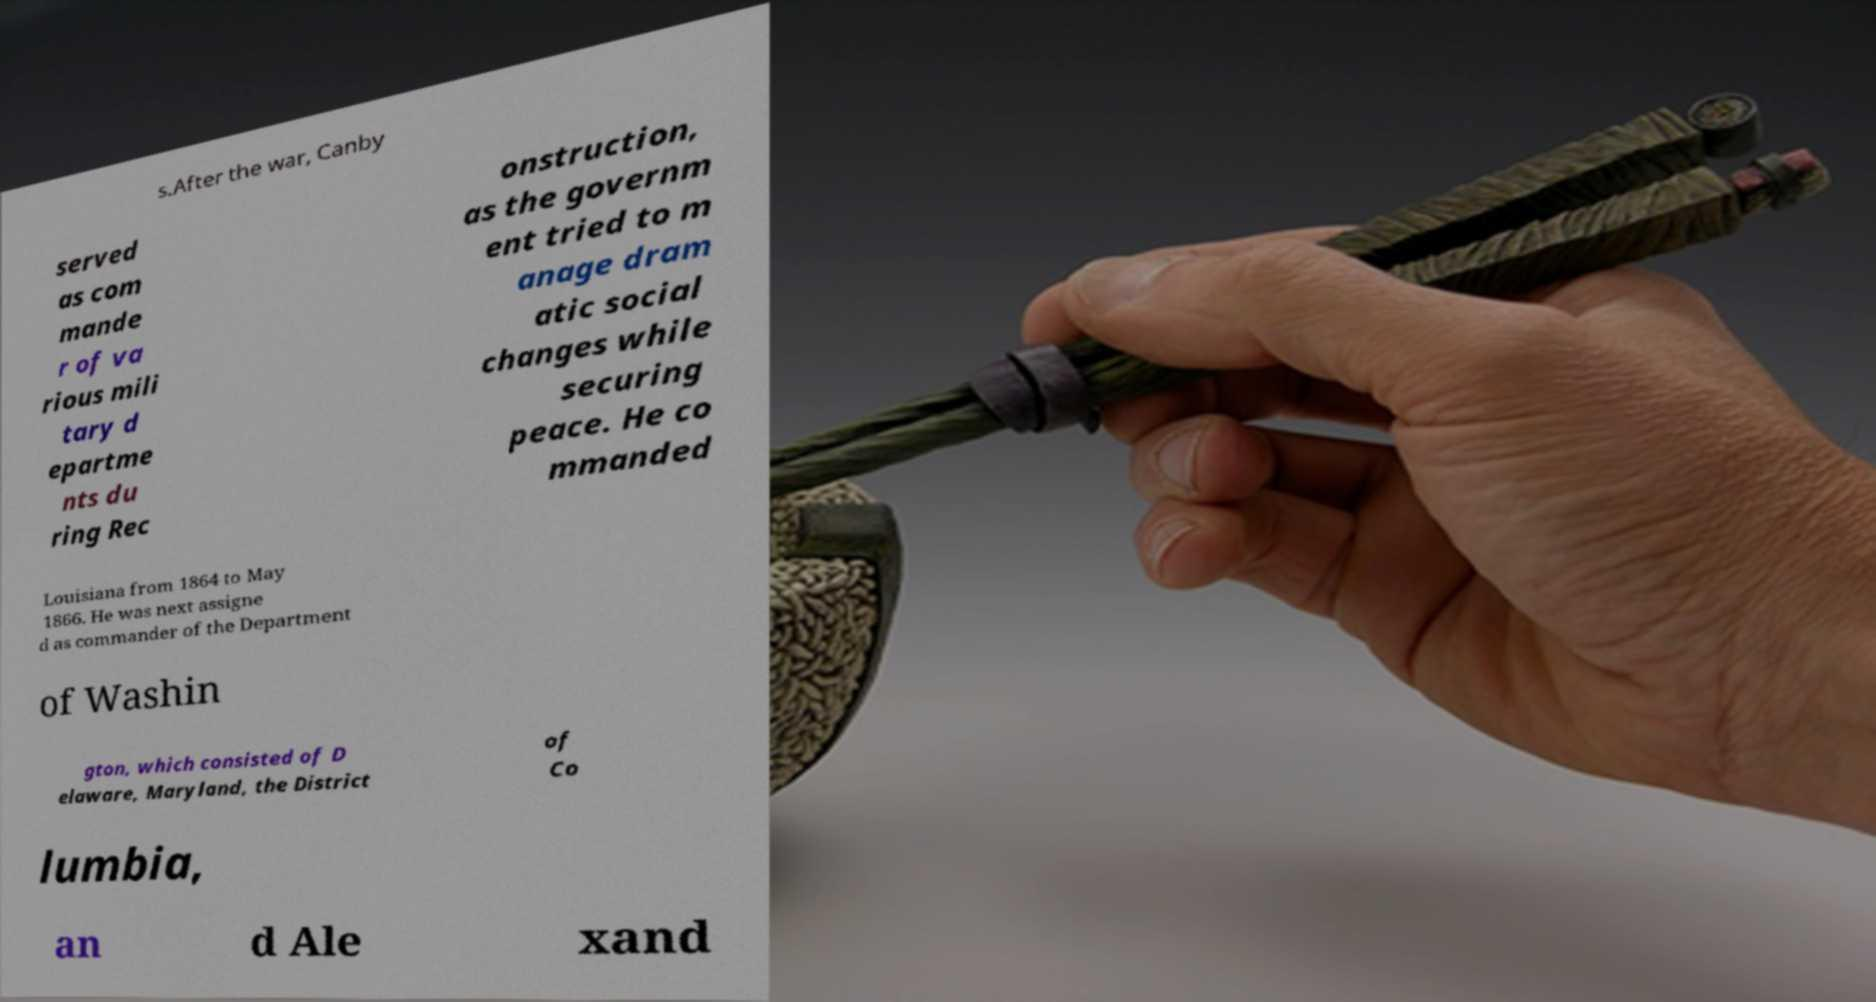Could you extract and type out the text from this image? s.After the war, Canby served as com mande r of va rious mili tary d epartme nts du ring Rec onstruction, as the governm ent tried to m anage dram atic social changes while securing peace. He co mmanded Louisiana from 1864 to May 1866. He was next assigne d as commander of the Department of Washin gton, which consisted of D elaware, Maryland, the District of Co lumbia, an d Ale xand 